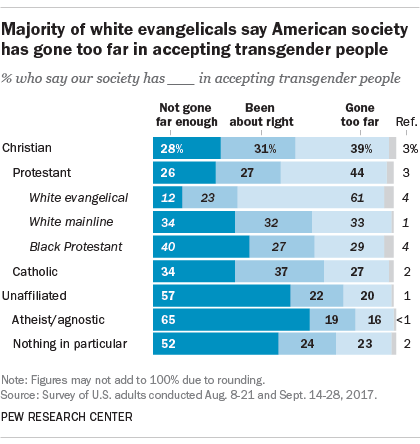Specify some key components in this picture. The average of all the bars for Christian is smaller than the largest value of "Gone too far" bars. According to a survey conducted by Pew Research Center, 34% of Catholic respondents believe that our society has not gone far enough in accepting transgender people. 